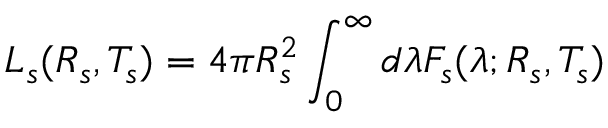<formula> <loc_0><loc_0><loc_500><loc_500>L _ { s } ( R _ { s } , T _ { s } ) = 4 \pi R _ { s } ^ { 2 } \int _ { 0 } ^ { \infty } d \lambda F _ { s } ( \lambda ; R _ { s } , T _ { s } )</formula> 